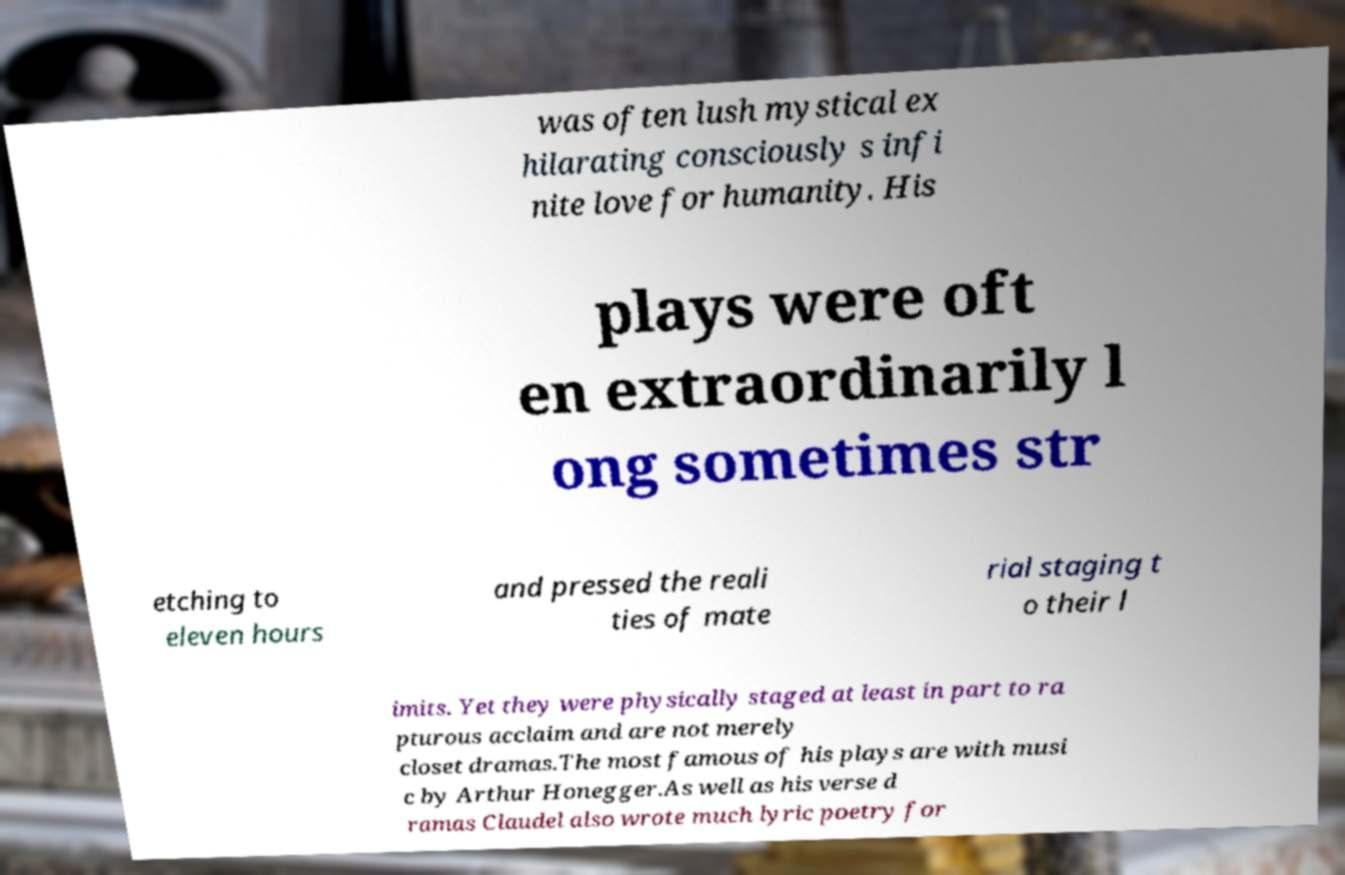I need the written content from this picture converted into text. Can you do that? was often lush mystical ex hilarating consciously s infi nite love for humanity. His plays were oft en extraordinarily l ong sometimes str etching to eleven hours and pressed the reali ties of mate rial staging t o their l imits. Yet they were physically staged at least in part to ra pturous acclaim and are not merely closet dramas.The most famous of his plays are with musi c by Arthur Honegger.As well as his verse d ramas Claudel also wrote much lyric poetry for 